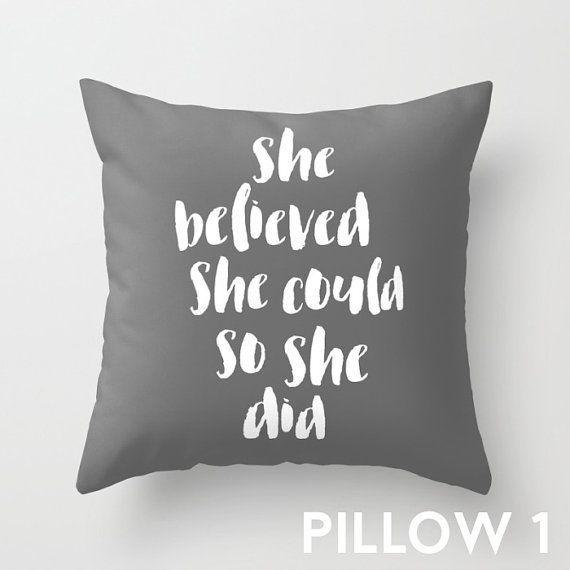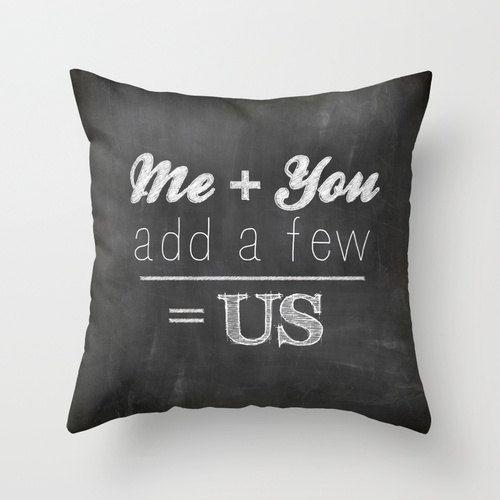The first image is the image on the left, the second image is the image on the right. Analyze the images presented: Is the assertion "IN at least one image there is a light gray pillow with at least five lines of white writing." valid? Answer yes or no. Yes. 